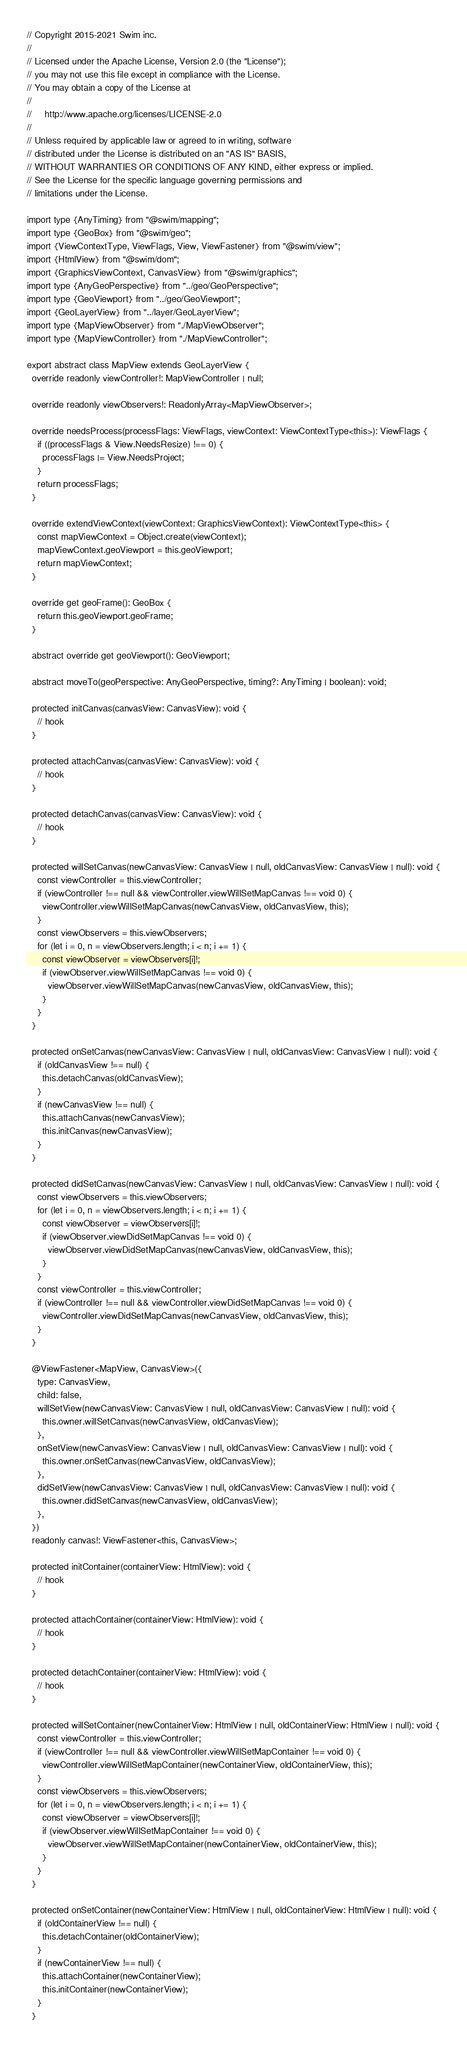Convert code to text. <code><loc_0><loc_0><loc_500><loc_500><_TypeScript_>// Copyright 2015-2021 Swim inc.
//
// Licensed under the Apache License, Version 2.0 (the "License");
// you may not use this file except in compliance with the License.
// You may obtain a copy of the License at
//
//     http://www.apache.org/licenses/LICENSE-2.0
//
// Unless required by applicable law or agreed to in writing, software
// distributed under the License is distributed on an "AS IS" BASIS,
// WITHOUT WARRANTIES OR CONDITIONS OF ANY KIND, either express or implied.
// See the License for the specific language governing permissions and
// limitations under the License.

import type {AnyTiming} from "@swim/mapping";
import type {GeoBox} from "@swim/geo";
import {ViewContextType, ViewFlags, View, ViewFastener} from "@swim/view";
import {HtmlView} from "@swim/dom";
import {GraphicsViewContext, CanvasView} from "@swim/graphics";
import type {AnyGeoPerspective} from "../geo/GeoPerspective";
import type {GeoViewport} from "../geo/GeoViewport";
import {GeoLayerView} from "../layer/GeoLayerView";
import type {MapViewObserver} from "./MapViewObserver";
import type {MapViewController} from "./MapViewController";

export abstract class MapView extends GeoLayerView {
  override readonly viewController!: MapViewController | null;

  override readonly viewObservers!: ReadonlyArray<MapViewObserver>;

  override needsProcess(processFlags: ViewFlags, viewContext: ViewContextType<this>): ViewFlags {
    if ((processFlags & View.NeedsResize) !== 0) {
      processFlags |= View.NeedsProject;
    }
    return processFlags;
  }

  override extendViewContext(viewContext: GraphicsViewContext): ViewContextType<this> {
    const mapViewContext = Object.create(viewContext);
    mapViewContext.geoViewport = this.geoViewport;
    return mapViewContext;
  }

  override get geoFrame(): GeoBox {
    return this.geoViewport.geoFrame;
  }

  abstract override get geoViewport(): GeoViewport;

  abstract moveTo(geoPerspective: AnyGeoPerspective, timing?: AnyTiming | boolean): void;

  protected initCanvas(canvasView: CanvasView): void {
    // hook
  }

  protected attachCanvas(canvasView: CanvasView): void {
    // hook
  }

  protected detachCanvas(canvasView: CanvasView): void {
    // hook
  }

  protected willSetCanvas(newCanvasView: CanvasView | null, oldCanvasView: CanvasView | null): void {
    const viewController = this.viewController;
    if (viewController !== null && viewController.viewWillSetMapCanvas !== void 0) {
      viewController.viewWillSetMapCanvas(newCanvasView, oldCanvasView, this);
    }
    const viewObservers = this.viewObservers;
    for (let i = 0, n = viewObservers.length; i < n; i += 1) {
      const viewObserver = viewObservers[i]!;
      if (viewObserver.viewWillSetMapCanvas !== void 0) {
        viewObserver.viewWillSetMapCanvas(newCanvasView, oldCanvasView, this);
      }
    }
  }

  protected onSetCanvas(newCanvasView: CanvasView | null, oldCanvasView: CanvasView | null): void {
    if (oldCanvasView !== null) {
      this.detachCanvas(oldCanvasView);
    }
    if (newCanvasView !== null) {
      this.attachCanvas(newCanvasView);
      this.initCanvas(newCanvasView);
    }
  }

  protected didSetCanvas(newCanvasView: CanvasView | null, oldCanvasView: CanvasView | null): void {
    const viewObservers = this.viewObservers;
    for (let i = 0, n = viewObservers.length; i < n; i += 1) {
      const viewObserver = viewObservers[i]!;
      if (viewObserver.viewDidSetMapCanvas !== void 0) {
        viewObserver.viewDidSetMapCanvas(newCanvasView, oldCanvasView, this);
      }
    }
    const viewController = this.viewController;
    if (viewController !== null && viewController.viewDidSetMapCanvas !== void 0) {
      viewController.viewDidSetMapCanvas(newCanvasView, oldCanvasView, this);
    }
  }

  @ViewFastener<MapView, CanvasView>({
    type: CanvasView,
    child: false,
    willSetView(newCanvasView: CanvasView | null, oldCanvasView: CanvasView | null): void {
      this.owner.willSetCanvas(newCanvasView, oldCanvasView);
    },
    onSetView(newCanvasView: CanvasView | null, oldCanvasView: CanvasView | null): void {
      this.owner.onSetCanvas(newCanvasView, oldCanvasView);
    },
    didSetView(newCanvasView: CanvasView | null, oldCanvasView: CanvasView | null): void {
      this.owner.didSetCanvas(newCanvasView, oldCanvasView);
    },
  })
  readonly canvas!: ViewFastener<this, CanvasView>;

  protected initContainer(containerView: HtmlView): void {
    // hook
  }

  protected attachContainer(containerView: HtmlView): void {
    // hook
  }

  protected detachContainer(containerView: HtmlView): void {
    // hook
  }

  protected willSetContainer(newContainerView: HtmlView | null, oldContainerView: HtmlView | null): void {
    const viewController = this.viewController;
    if (viewController !== null && viewController.viewWillSetMapContainer !== void 0) {
      viewController.viewWillSetMapContainer(newContainerView, oldContainerView, this);
    }
    const viewObservers = this.viewObservers;
    for (let i = 0, n = viewObservers.length; i < n; i += 1) {
      const viewObserver = viewObservers[i]!;
      if (viewObserver.viewWillSetMapContainer !== void 0) {
        viewObserver.viewWillSetMapContainer(newContainerView, oldContainerView, this);
      }
    }
  }

  protected onSetContainer(newContainerView: HtmlView | null, oldContainerView: HtmlView | null): void {
    if (oldContainerView !== null) {
      this.detachContainer(oldContainerView);
    }
    if (newContainerView !== null) {
      this.attachContainer(newContainerView);
      this.initContainer(newContainerView);
    }
  }
</code> 